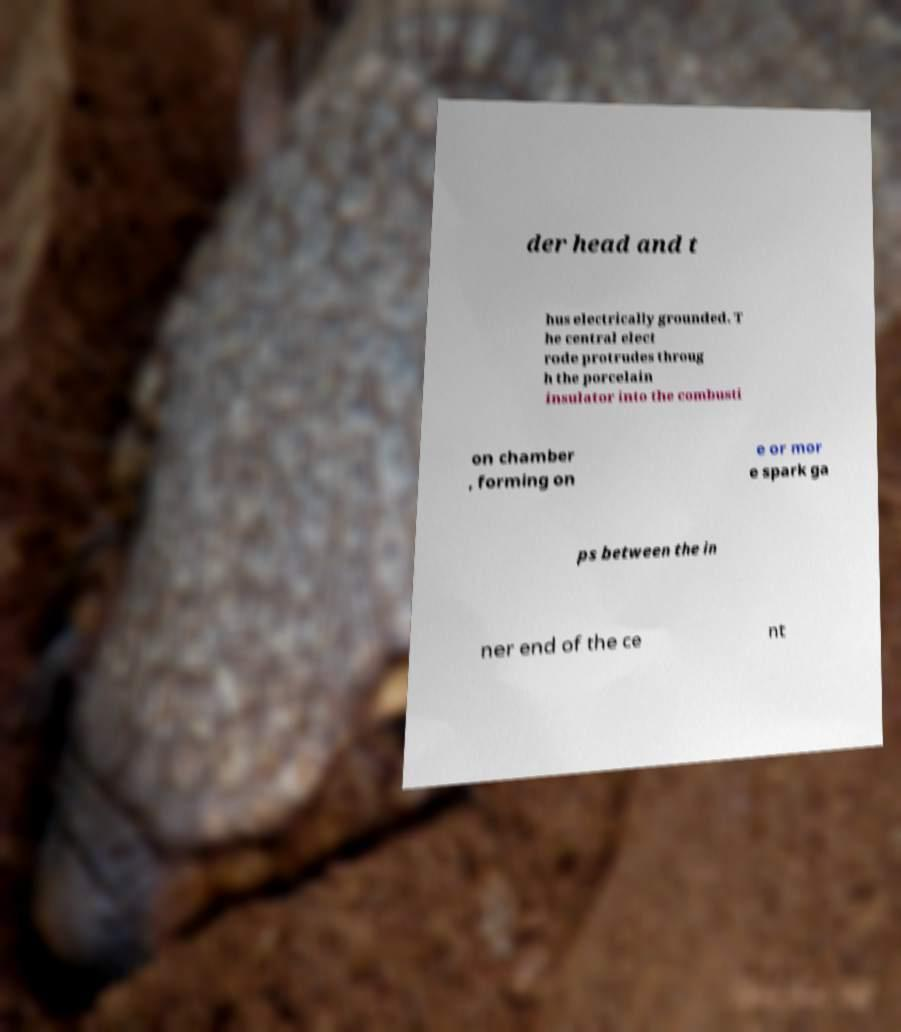Could you extract and type out the text from this image? der head and t hus electrically grounded. T he central elect rode protrudes throug h the porcelain insulator into the combusti on chamber , forming on e or mor e spark ga ps between the in ner end of the ce nt 